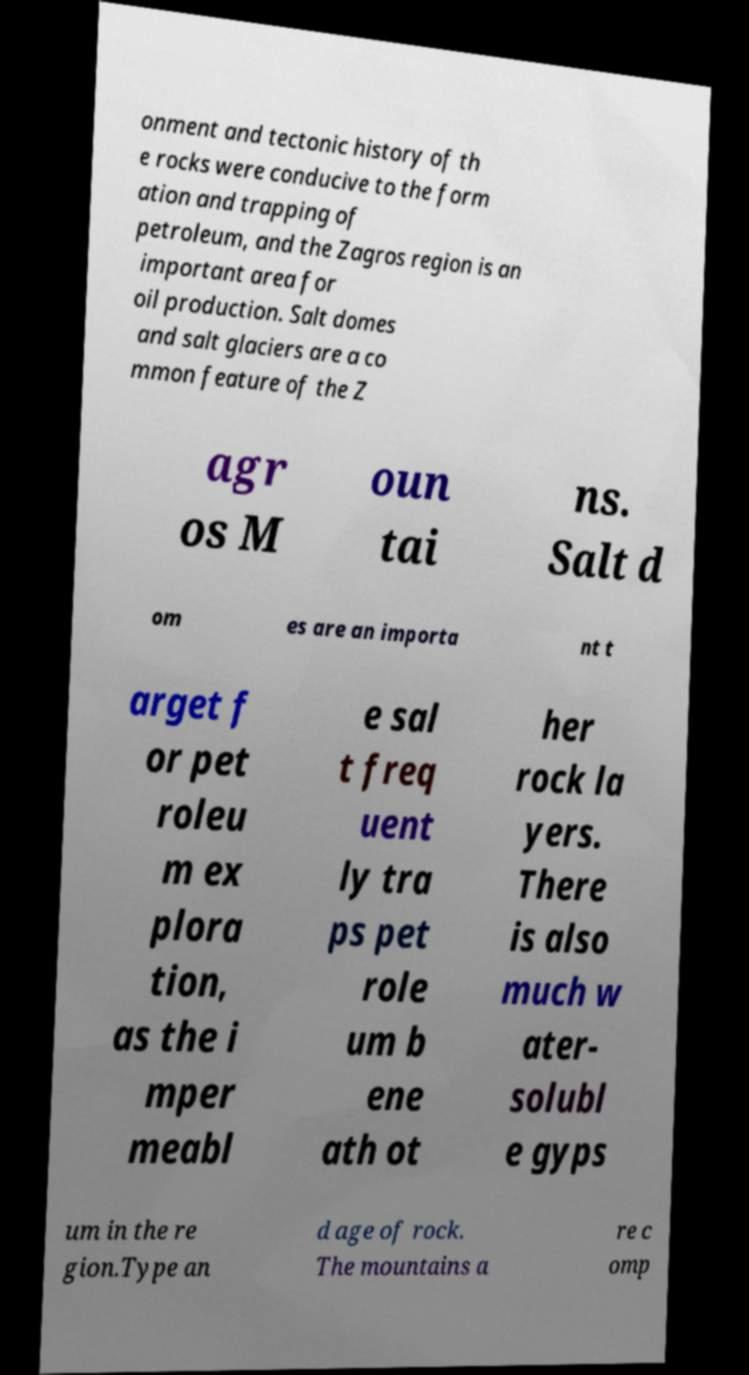Can you accurately transcribe the text from the provided image for me? onment and tectonic history of th e rocks were conducive to the form ation and trapping of petroleum, and the Zagros region is an important area for oil production. Salt domes and salt glaciers are a co mmon feature of the Z agr os M oun tai ns. Salt d om es are an importa nt t arget f or pet roleu m ex plora tion, as the i mper meabl e sal t freq uent ly tra ps pet role um b ene ath ot her rock la yers. There is also much w ater- solubl e gyps um in the re gion.Type an d age of rock. The mountains a re c omp 